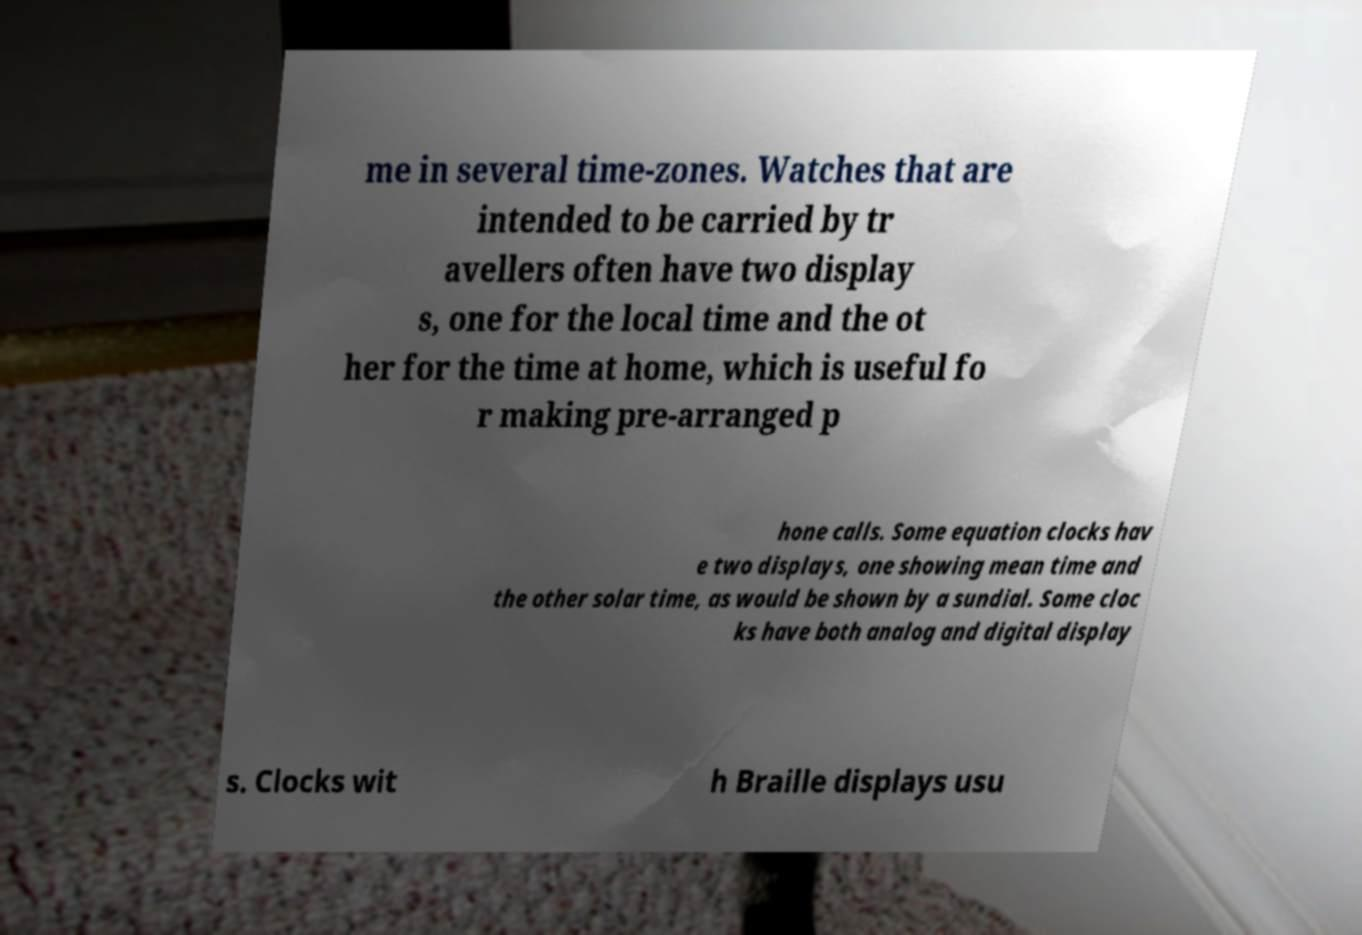Can you accurately transcribe the text from the provided image for me? me in several time-zones. Watches that are intended to be carried by tr avellers often have two display s, one for the local time and the ot her for the time at home, which is useful fo r making pre-arranged p hone calls. Some equation clocks hav e two displays, one showing mean time and the other solar time, as would be shown by a sundial. Some cloc ks have both analog and digital display s. Clocks wit h Braille displays usu 